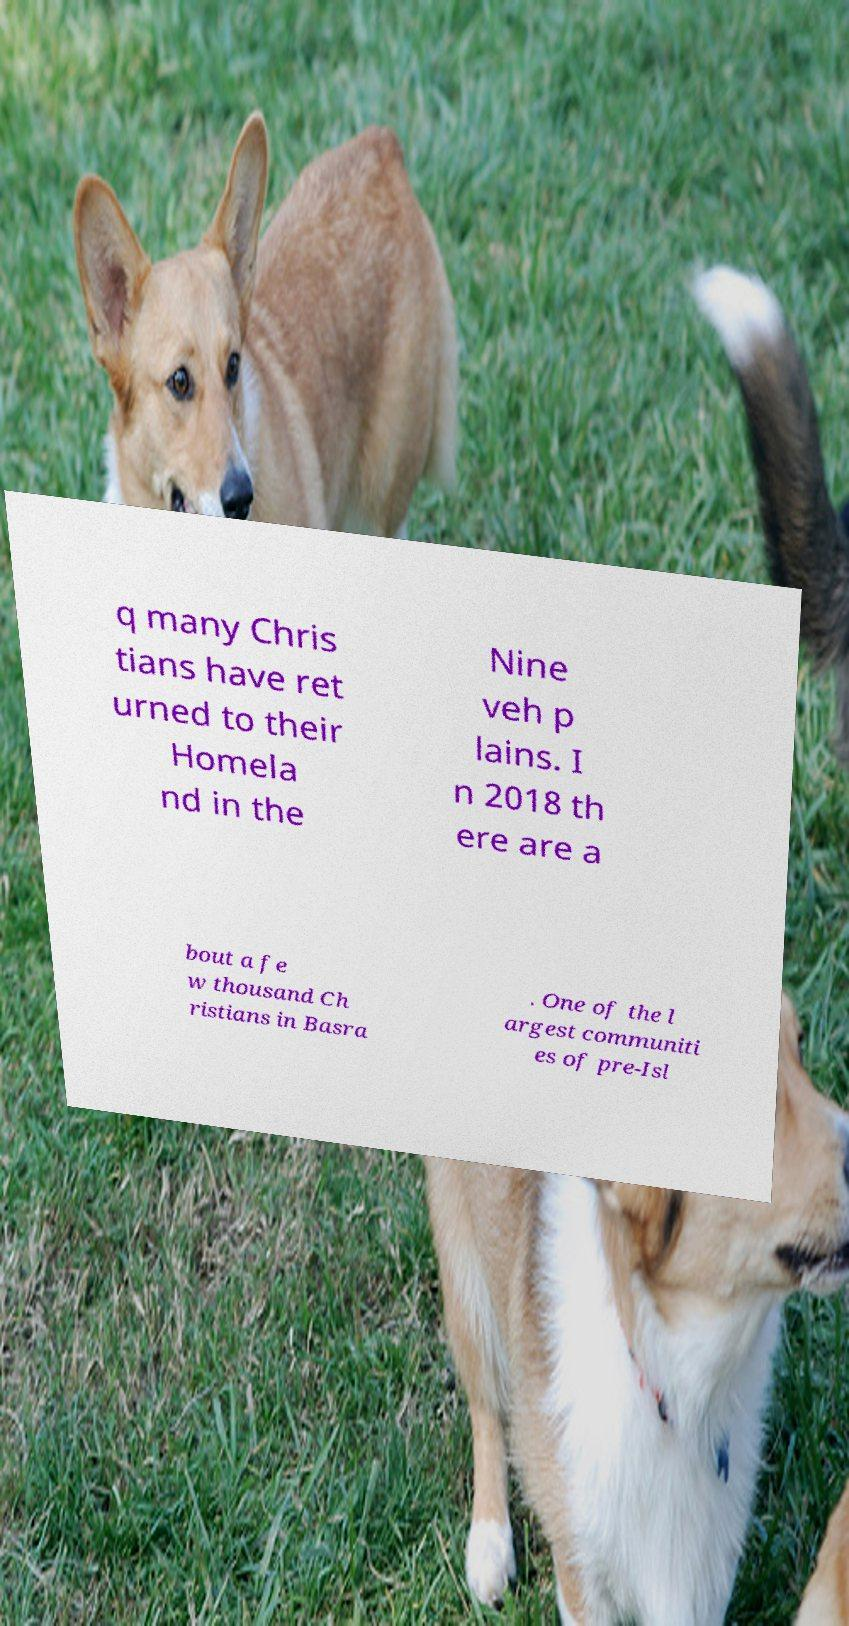Can you read and provide the text displayed in the image?This photo seems to have some interesting text. Can you extract and type it out for me? q many Chris tians have ret urned to their Homela nd in the Nine veh p lains. I n 2018 th ere are a bout a fe w thousand Ch ristians in Basra . One of the l argest communiti es of pre-Isl 